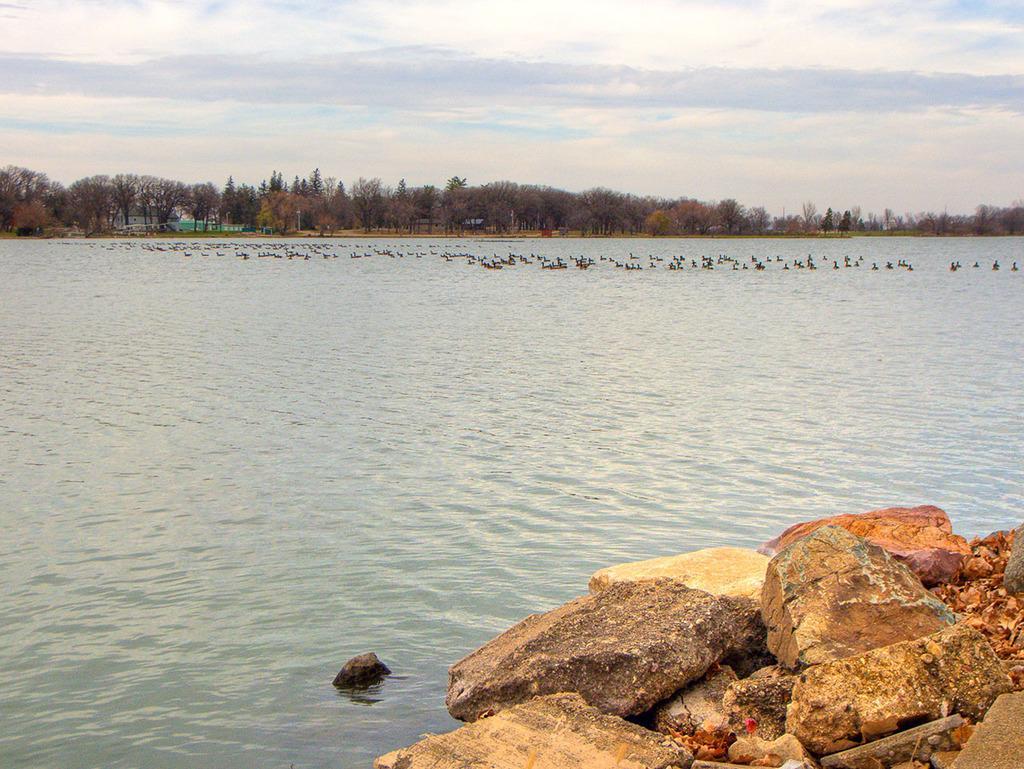Please provide a concise description of this image. In this image, I can see the water flowing. These are the rocks. I think these are the birds in the water. I can see the trees. This is the sky. 